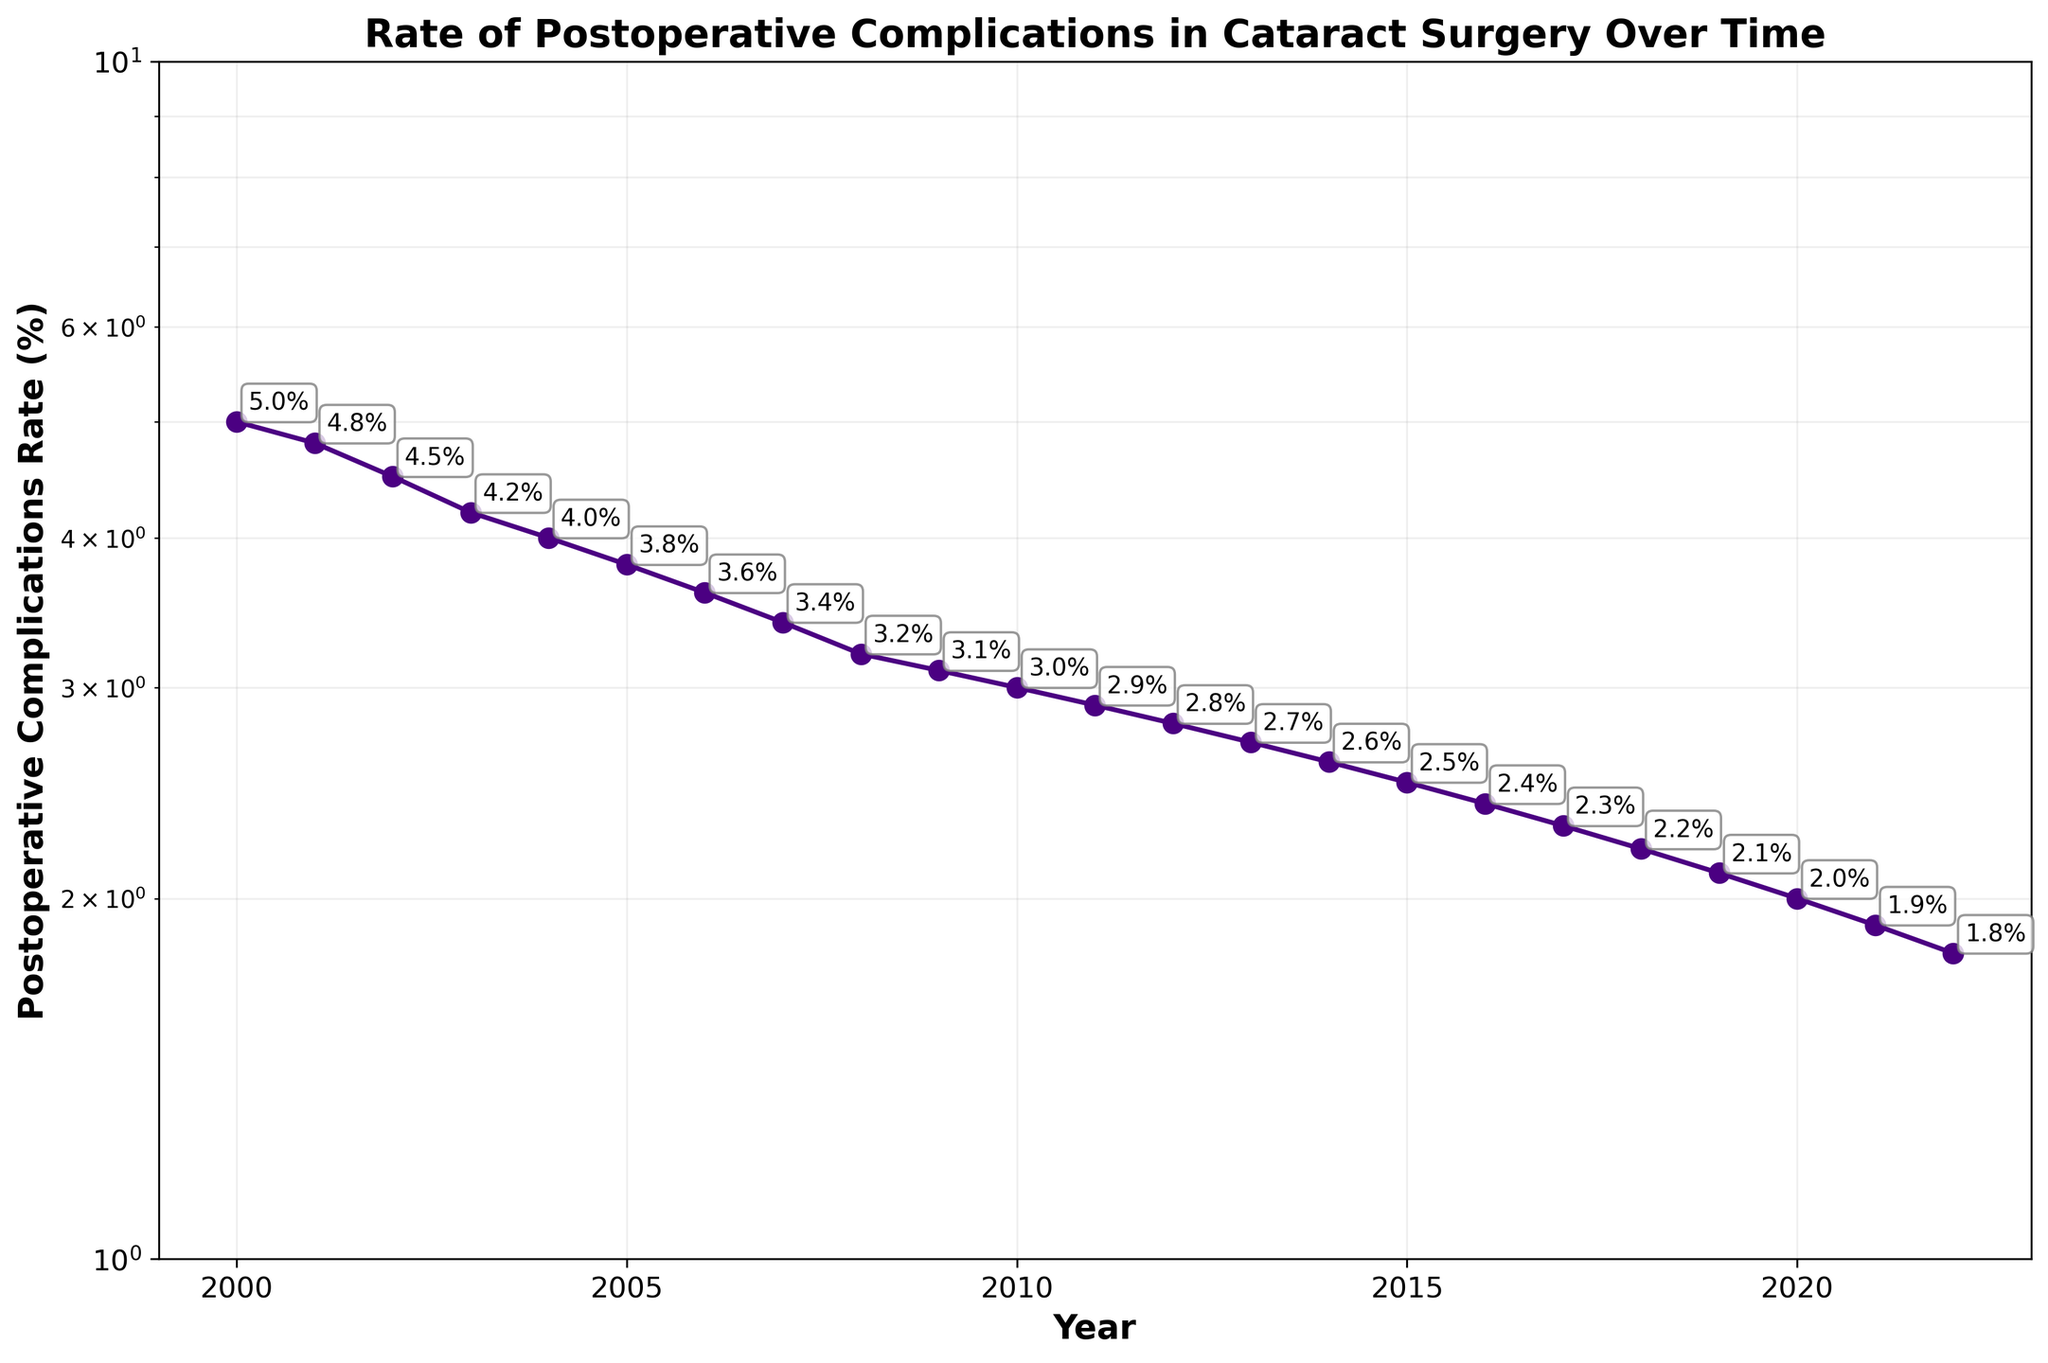What is the title of the plot? The title is found at the top of the plot and provides an overview of the data being displayed. In this case, the title is clear and reads "Rate of Postoperative Complications in Cataract Surgery Over Time".
Answer: Rate of Postoperative Complications in Cataract Surgery Over Time What is the x-axis label? The label on the x-axis informs us about the data represented on this axis. Here, the label "Year" indicates the years during which data was collected.
Answer: Year What is the y-axis label? The label on the y-axis informs us about the data represented on this axis. Here, the label "Postoperative Complications Rate (%)" indicates the percentage rate of postoperative complications.
Answer: Postoperative Complications Rate (%) What trend do you observe in the postoperative complications rate from 2000 to 2022? Observing the plot, the rate of postoperative complications decreases continuously from 5.0% in 2000 to 1.8% in 2022, indicating an overall improvement in surgical outcomes over these years.
Answer: Decreasing trend What was the rate of postoperative complications in the year 2010? By examining the plot and looking at the annotated points, the rate of postoperative complications in 2010 can be directly read off as 3.0%.
Answer: 3.0% Between which years do we observe the steepest decline in the rate of postoperative complications? To determine this, observe the slope between each successive pair of years. The steepest decline is seen between 2000 and 2001, where the rate drops from 5.0% to 4.8%, which is a decrease of 0.2%.
Answer: 2000 to 2001 How much did the postoperative complications rate decrease from 2000 to 2022? To calculate the decrease, subtract the rate in 2022 from the rate in 2000: 5.0% - 1.8% = 3.2%.
Answer: 3.2% Which year has the lowest rate of postoperative complications? By observing all the data points in the plot, the year with the lowest rate is 2022, with a rate of 1.8%.
Answer: 2022 Which years experienced a postoperative complications rate of exactly 3.0%? By checking the annotations, the plot shows that the rate was exactly 3.0% in the year 2010.
Answer: 2010 Is the rate of postoperative complications in 2021 less than or greater than 3%? From the plot annotations, the rate in 2021 is 1.9%, which is less than 3%.
Answer: Less than 3% 